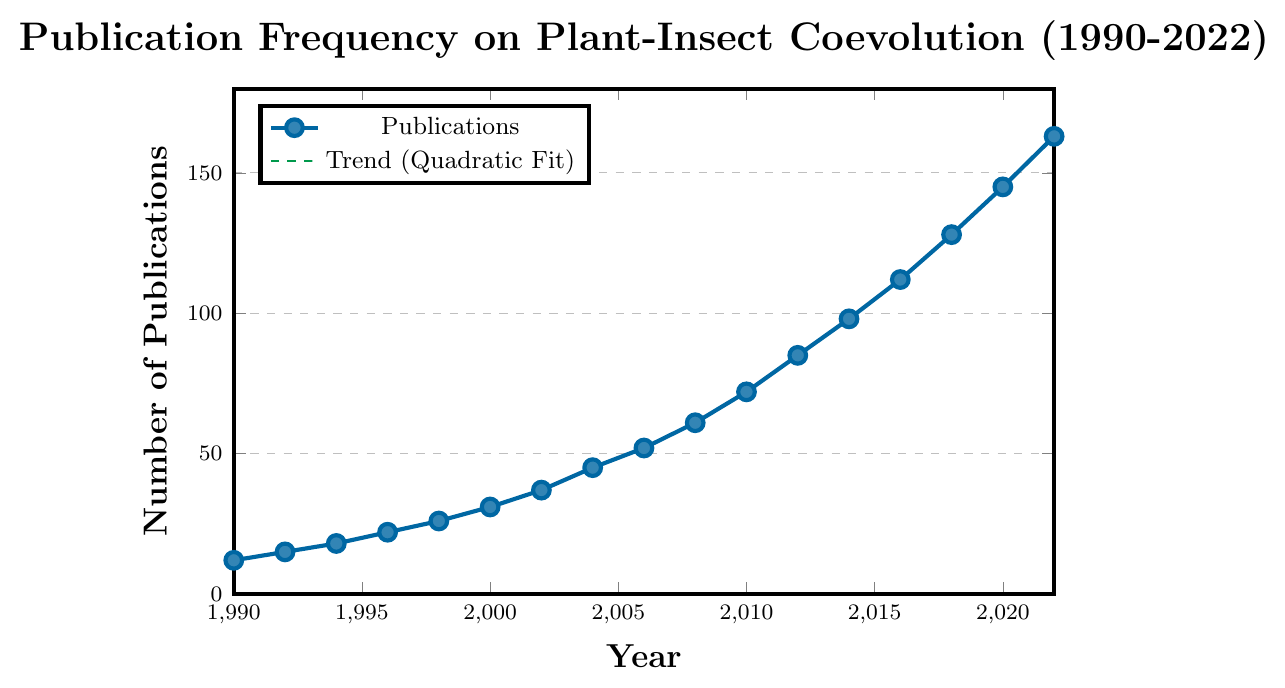What is the total number of publications in the year 2000 and 2010? Look at the figure and find the number of publications for the years 2000 and 2010. Add them together: 31 (in 2000) + 72 (in 2010) = 103.
Answer: 103 In which year did the number of publications first exceed 100? Observe the x-axis for the publication count and find when it first surpasses 100. The chart shows that this happens in 2014.
Answer: 2014 What is the trend of the publication frequency over the years 1990 to 2022? The trend line, indicated by the dashed green line, shows a quadratic growth, indicating an accelerating increase in publication frequency over time.
Answer: Quadratic growth How many more publications were there in 2022 compared to 1990? Subtract the number of publications in 1990 from the number in 2022: 163 (in 2022) - 12 (in 1990) = 151.
Answer: 151 Identify the period with the steepest increase in publications. By observing the slope of the line, the steepest increase is seen around the 2010 to 2014 period where the rise in publications is quite rapid.
Answer: 2010 to 2014 What is the average annual number of publications between 1990 and 2000? Sum the publications from 1990 to 2000 then divide by the number of years (6 data points): (12 + 15 + 18 + 22 + 26 + 31)/6 = 124/6 ≈ 20.67
Answer: 20.67 Compare the number of publications in the years 1996 and 2004. Which year had more and by how much? Look at the values for 1996 (22 publications) and 2004 (45 publications). Subtract to find the difference: 45 - 22 = 23.
Answer: 2004, by 23 Which year had double the number of publications compared to the year 2000? The publication count in 2000 is 31. Look for the year where publications are approximately double that number: 2 * 31 = 62. The closest matching year is 2008 with 61 publications.
Answer: 2008 How does the magnitude of the increase in publications from 2002 to 2012 compare to that from 2012 to 2022? Calculate the increase for each period: 2012 - 2002 (85 - 37 = 48) and 2022 - 2012 (163 - 85 = 78). Compare: 48 < 78.
Answer: 2012 to 2022 had a larger increase by 30 publications What is the color of the trend line in the chart? The trend line, fitted with a quadratic model, is drawn in green.
Answer: Green 